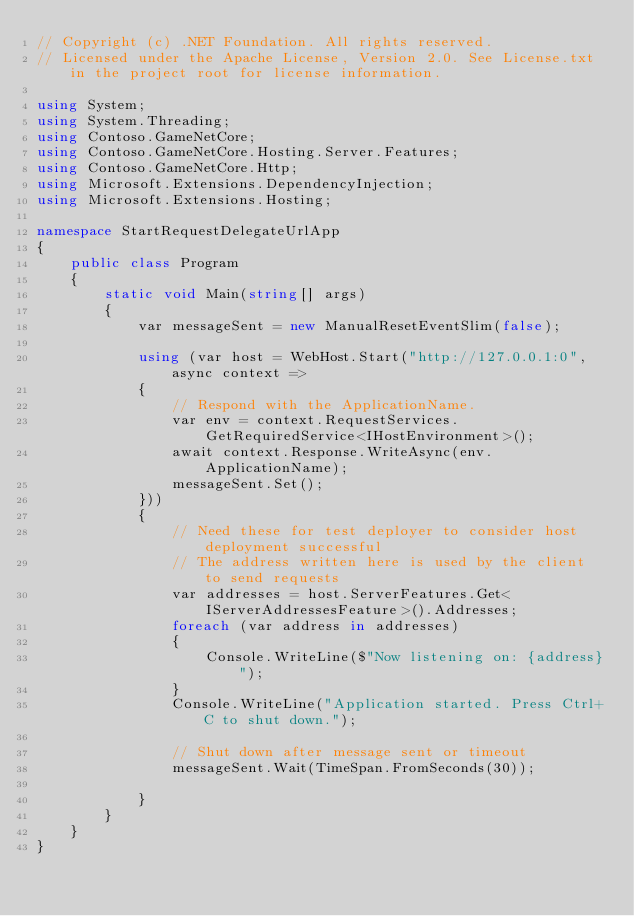<code> <loc_0><loc_0><loc_500><loc_500><_C#_>// Copyright (c) .NET Foundation. All rights reserved.
// Licensed under the Apache License, Version 2.0. See License.txt in the project root for license information.

using System;
using System.Threading;
using Contoso.GameNetCore;
using Contoso.GameNetCore.Hosting.Server.Features;
using Contoso.GameNetCore.Http;
using Microsoft.Extensions.DependencyInjection;
using Microsoft.Extensions.Hosting;

namespace StartRequestDelegateUrlApp
{
    public class Program
    {
        static void Main(string[] args)
        {
            var messageSent = new ManualResetEventSlim(false);

            using (var host = WebHost.Start("http://127.0.0.1:0", async context =>
            {
                // Respond with the ApplicationName.
                var env = context.RequestServices.GetRequiredService<IHostEnvironment>();
                await context.Response.WriteAsync(env.ApplicationName);
                messageSent.Set();
            }))
            {
                // Need these for test deployer to consider host deployment successful
                // The address written here is used by the client to send requests
                var addresses = host.ServerFeatures.Get<IServerAddressesFeature>().Addresses;
                foreach (var address in addresses)
                {
                    Console.WriteLine($"Now listening on: {address}");
                }
                Console.WriteLine("Application started. Press Ctrl+C to shut down.");

                // Shut down after message sent or timeout
                messageSent.Wait(TimeSpan.FromSeconds(30));

            }
        }
    }
}
</code> 